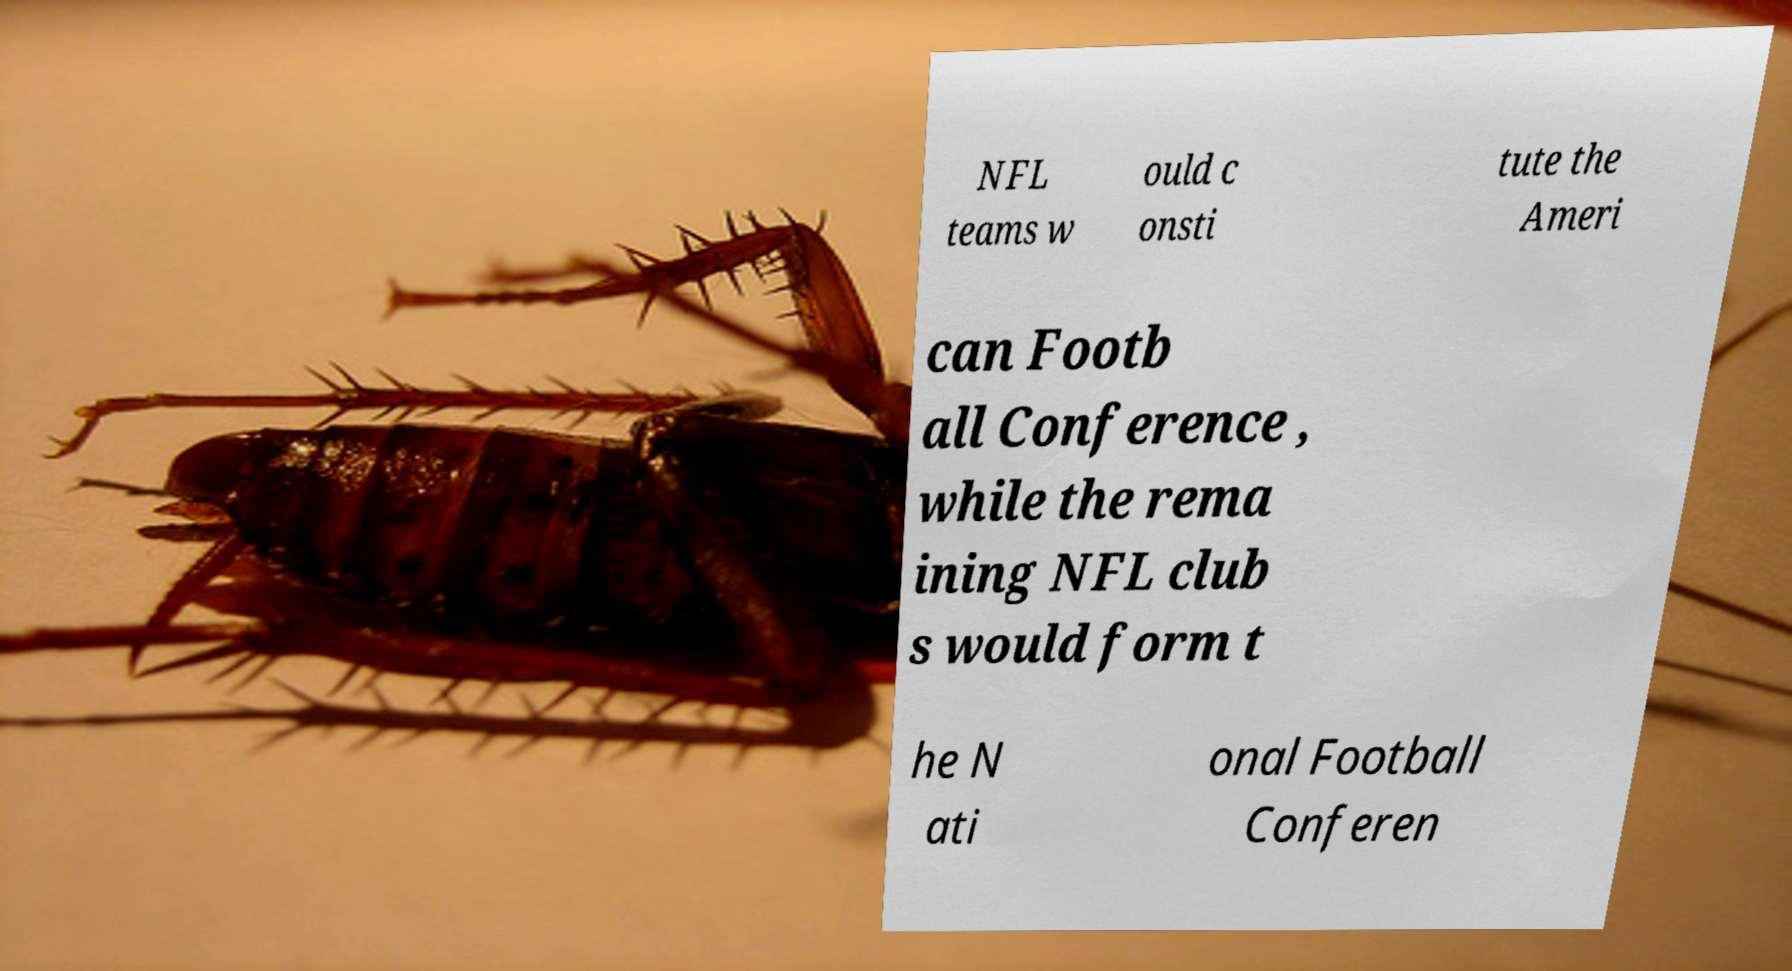Can you accurately transcribe the text from the provided image for me? NFL teams w ould c onsti tute the Ameri can Footb all Conference , while the rema ining NFL club s would form t he N ati onal Football Conferen 